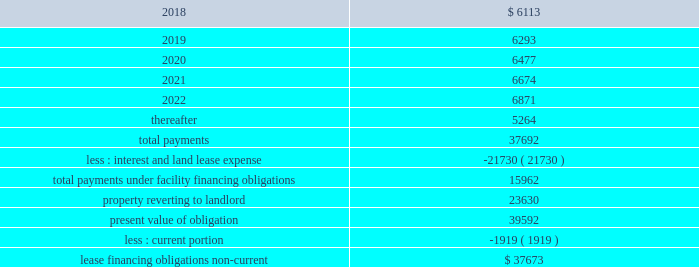As of december 31 , 2017 , the future minimum payments due under the lease financing obligation were as follows ( in thousands ) : years ending december 31 .
Purchase commitments we outsource most of our manufacturing and supply chain management operations to third-party contract manufacturers , who procure components and assemble products on our behalf based on our forecasts in order to reduce manufacturing lead times and ensure adequate component supply .
We issue purchase orders to our contract manufacturers for finished product and a significant portion of these orders consist of firm non-cancellable commitments .
In addition , we purchase strategic component inventory from certain suppliers under purchase commitments that in some cases are non-cancellable , including integrated circuits , which are consigned to our contract manufacturers .
As of december 31 , 2017 , we had non-cancellable purchase commitments of $ 195.1 million , of which $ 147.9 million was to our contract manufacturers and suppliers .
In addition , we have provided deposits to secure our obligations to purchase inventory .
We had $ 36.9 million and $ 63.1 million in deposits as of december 31 , 2017 and 2016 , respectively .
These deposits are classified in 'prepaid expenses and other current assets' and 'other assets' in our accompanying consolidated balance sheets .
Guarantees we have entered into agreements with some of our direct customers and channel partners that contain indemnification provisions relating to potential situations where claims could be alleged that our products infringe the intellectual property rights of a third party .
We have at our option and expense the ability to repair any infringement , replace product with a non-infringing equivalent-in-function product or refund our customers all or a portion of the value of the product .
Other guarantees or indemnification agreements include guarantees of product and service performance and standby letters of credit for leased facilities and corporate credit cards .
We have not recorded a liability related to these indemnification and guarantee provisions and our guarantee and indemnification arrangements have not had any significant impact on our consolidated financial statements to date .
Legal proceedings optumsoft , inc .
Matters on april 4 , 2014 , optumsoft filed a lawsuit against us in the superior court of california , santa clara county titled optumsoft , inc .
Arista networks , inc. , in which it asserts ( i ) ownership of certain components of our eos network operating system pursuant to the terms of a 2004 agreement between the companies ; and ( ii ) breaches of certain confidentiality and use restrictions in that agreement .
Under the terms of the 2004 agreement , optumsoft provided us with a non-exclusive , irrevocable , royalty-free license to software delivered by optumsoft comprising a software tool used to develop certain components of eos and a runtime library that is incorporated .
As of december 31 , 2017 , are future lease commitments greater than purchase commitments for contract manufacturers and suppliers? 
Computations: ((147.9 / 1000) > 37692)
Answer: no. 